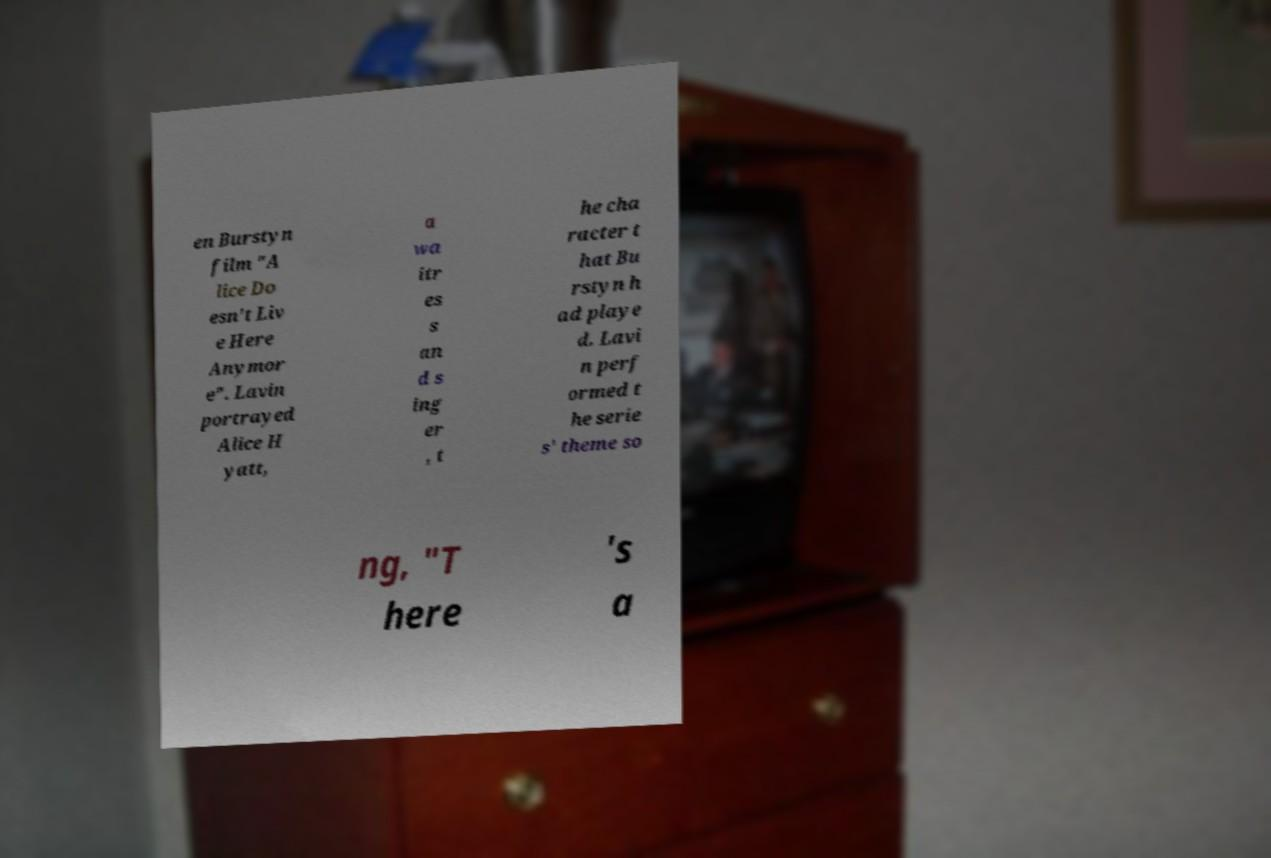Could you assist in decoding the text presented in this image and type it out clearly? en Burstyn film "A lice Do esn't Liv e Here Anymor e". Lavin portrayed Alice H yatt, a wa itr es s an d s ing er , t he cha racter t hat Bu rstyn h ad playe d. Lavi n perf ormed t he serie s' theme so ng, "T here 's a 